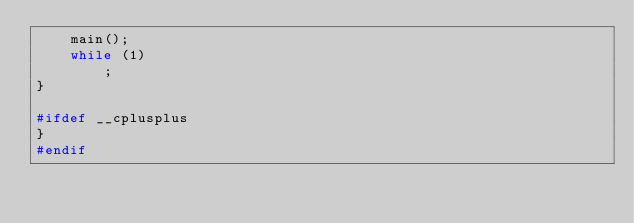<code> <loc_0><loc_0><loc_500><loc_500><_C_>    main();
    while (1)
        ;
}

#ifdef __cplusplus
}
#endif</code> 